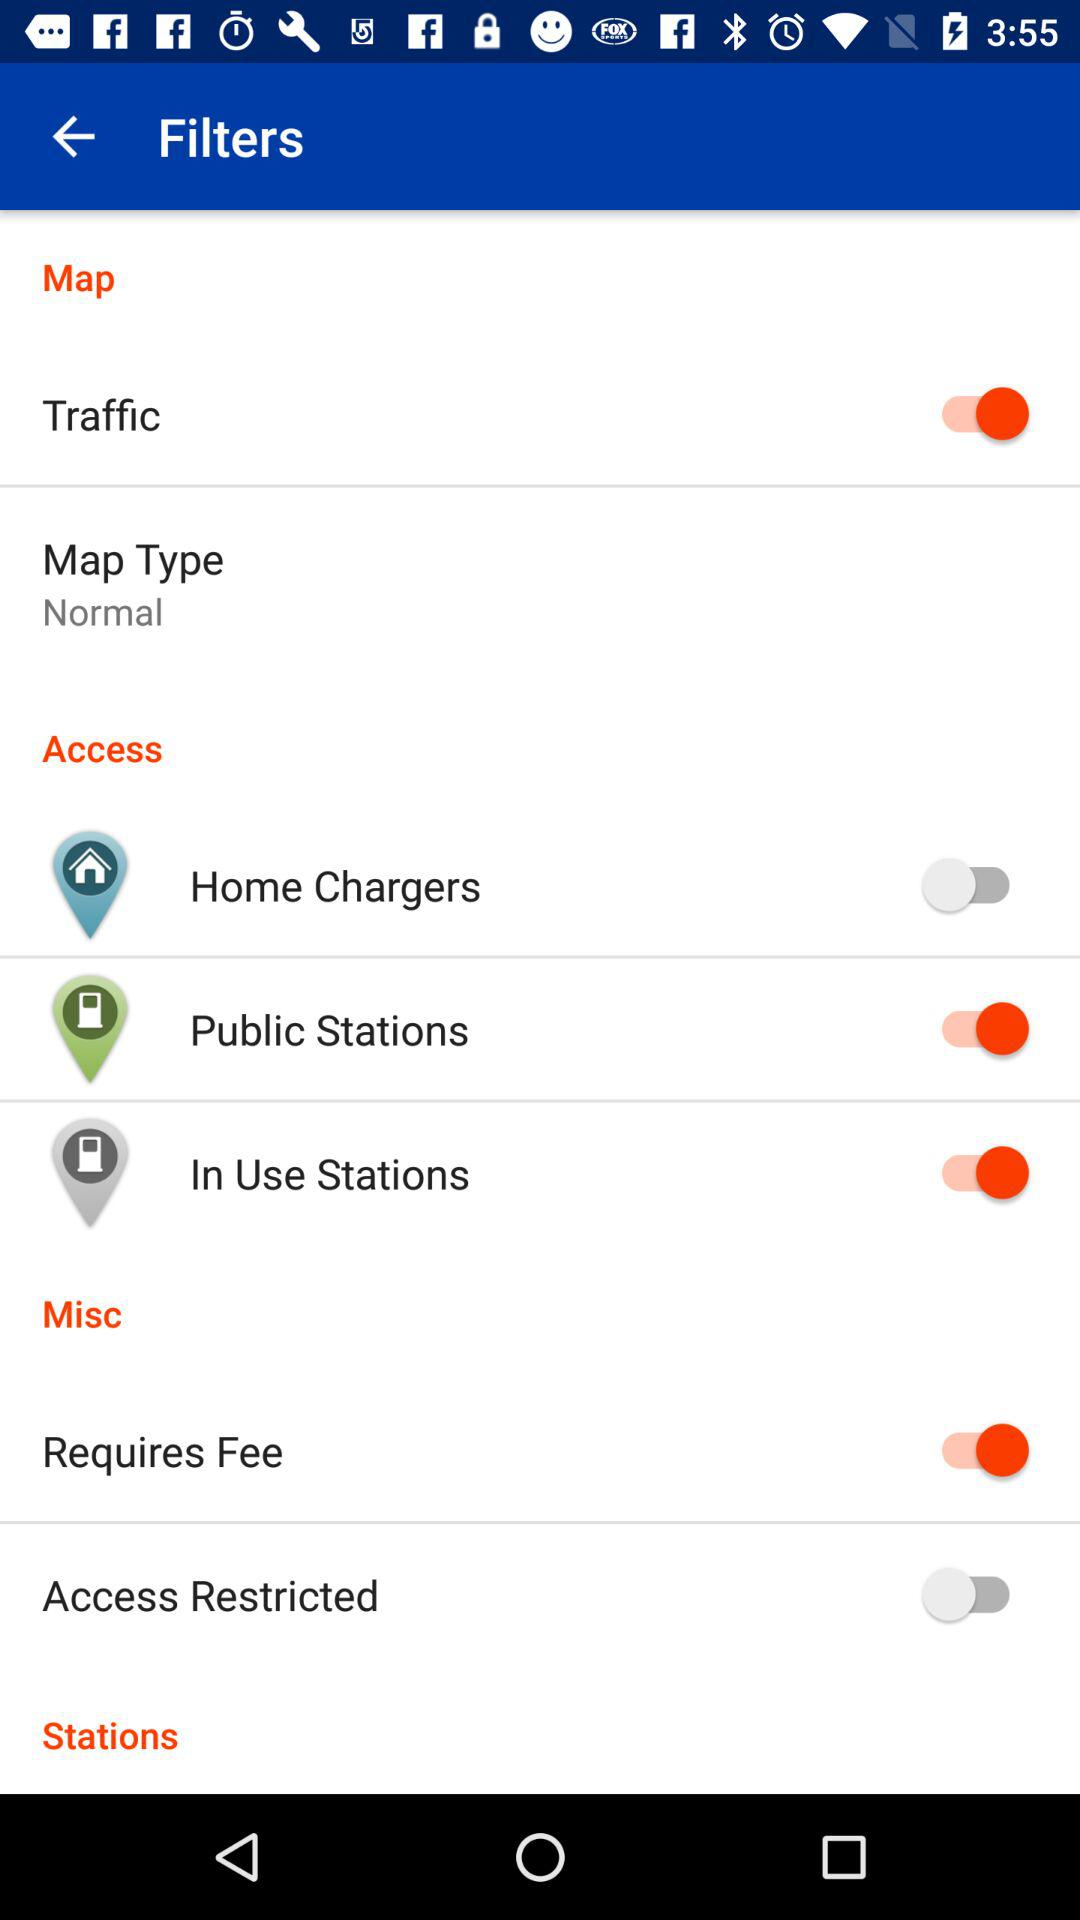What is the status of "Traffic"? The status is "on". 